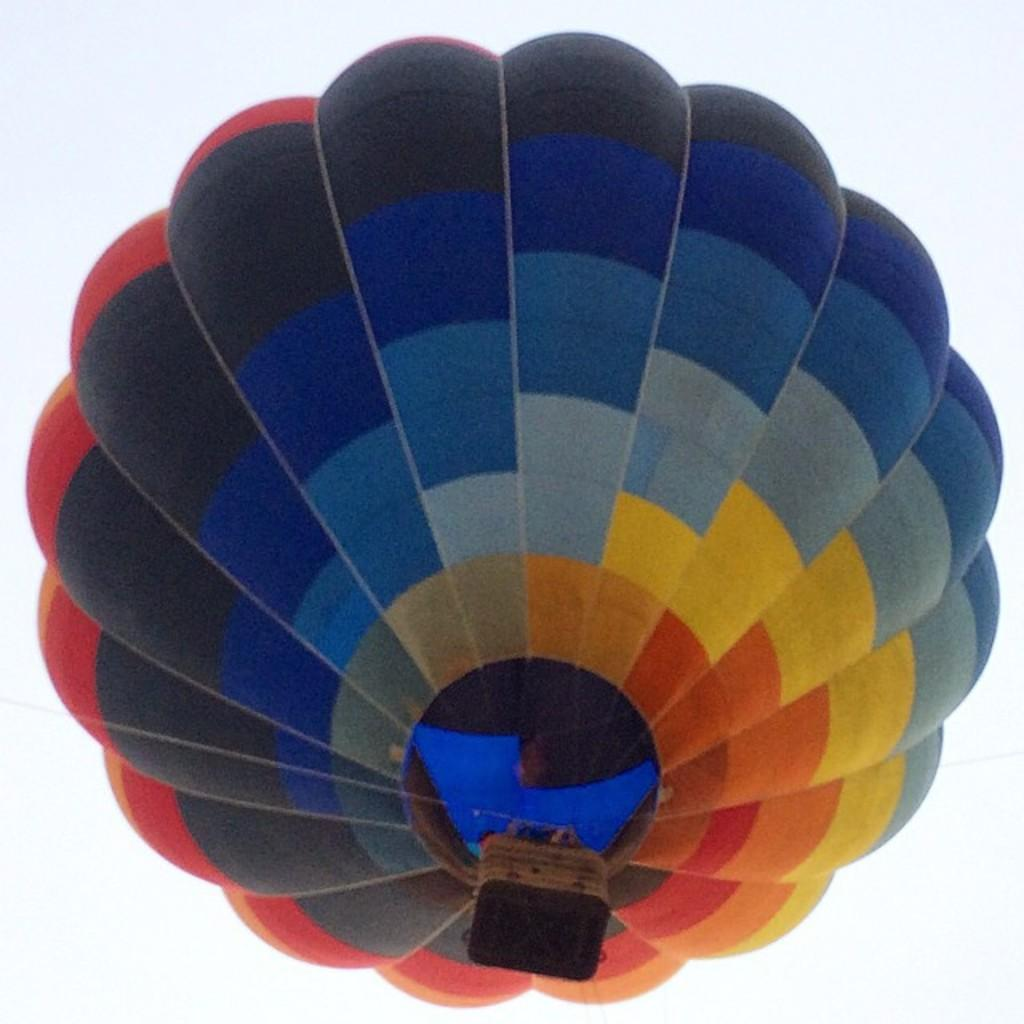What is the main subject of the image? There is a hot air balloon in the image. What type of humor can be seen in the image involving a goat and a cup? There is no humor, goat, or cup present in the image; it features a hot air balloon. 